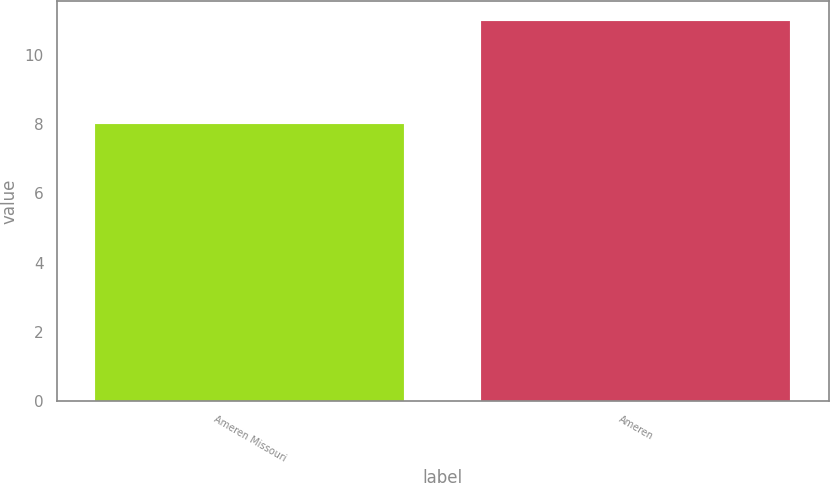Convert chart to OTSL. <chart><loc_0><loc_0><loc_500><loc_500><bar_chart><fcel>Ameren Missouri<fcel>Ameren<nl><fcel>8<fcel>11<nl></chart> 